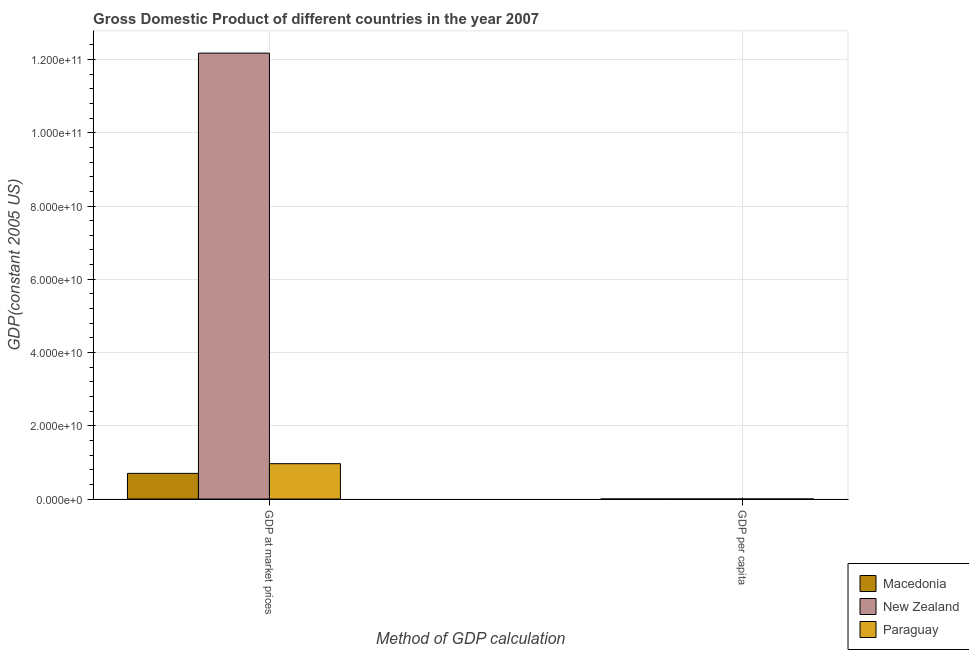How many different coloured bars are there?
Give a very brief answer. 3. Are the number of bars on each tick of the X-axis equal?
Provide a succinct answer. Yes. How many bars are there on the 2nd tick from the left?
Your response must be concise. 3. How many bars are there on the 1st tick from the right?
Keep it short and to the point. 3. What is the label of the 2nd group of bars from the left?
Offer a very short reply. GDP per capita. What is the gdp per capita in Macedonia?
Give a very brief answer. 3415.22. Across all countries, what is the maximum gdp at market prices?
Make the answer very short. 1.22e+11. Across all countries, what is the minimum gdp per capita?
Make the answer very short. 1617.6. In which country was the gdp at market prices maximum?
Your answer should be very brief. New Zealand. In which country was the gdp at market prices minimum?
Your answer should be very brief. Macedonia. What is the total gdp per capita in the graph?
Keep it short and to the point. 3.39e+04. What is the difference between the gdp per capita in New Zealand and that in Paraguay?
Your answer should be compact. 2.72e+04. What is the difference between the gdp at market prices in New Zealand and the gdp per capita in Macedonia?
Provide a succinct answer. 1.22e+11. What is the average gdp at market prices per country?
Your response must be concise. 4.61e+1. What is the difference between the gdp per capita and gdp at market prices in Macedonia?
Your response must be concise. -7.01e+09. In how many countries, is the gdp at market prices greater than 112000000000 US$?
Offer a terse response. 1. What is the ratio of the gdp at market prices in Macedonia to that in Paraguay?
Ensure brevity in your answer.  0.73. Is the gdp at market prices in Macedonia less than that in Paraguay?
Keep it short and to the point. Yes. What does the 3rd bar from the left in GDP at market prices represents?
Ensure brevity in your answer.  Paraguay. What does the 1st bar from the right in GDP at market prices represents?
Keep it short and to the point. Paraguay. How many bars are there?
Make the answer very short. 6. What is the difference between two consecutive major ticks on the Y-axis?
Give a very brief answer. 2.00e+1. Are the values on the major ticks of Y-axis written in scientific E-notation?
Give a very brief answer. Yes. Does the graph contain any zero values?
Ensure brevity in your answer.  No. Where does the legend appear in the graph?
Provide a succinct answer. Bottom right. How many legend labels are there?
Make the answer very short. 3. How are the legend labels stacked?
Make the answer very short. Vertical. What is the title of the graph?
Provide a short and direct response. Gross Domestic Product of different countries in the year 2007. Does "Small states" appear as one of the legend labels in the graph?
Your response must be concise. No. What is the label or title of the X-axis?
Your response must be concise. Method of GDP calculation. What is the label or title of the Y-axis?
Make the answer very short. GDP(constant 2005 US). What is the GDP(constant 2005 US) of Macedonia in GDP at market prices?
Your answer should be compact. 7.01e+09. What is the GDP(constant 2005 US) in New Zealand in GDP at market prices?
Make the answer very short. 1.22e+11. What is the GDP(constant 2005 US) of Paraguay in GDP at market prices?
Ensure brevity in your answer.  9.65e+09. What is the GDP(constant 2005 US) of Macedonia in GDP per capita?
Your answer should be compact. 3415.22. What is the GDP(constant 2005 US) in New Zealand in GDP per capita?
Ensure brevity in your answer.  2.88e+04. What is the GDP(constant 2005 US) of Paraguay in GDP per capita?
Offer a terse response. 1617.6. Across all Method of GDP calculation, what is the maximum GDP(constant 2005 US) in Macedonia?
Your answer should be very brief. 7.01e+09. Across all Method of GDP calculation, what is the maximum GDP(constant 2005 US) in New Zealand?
Offer a terse response. 1.22e+11. Across all Method of GDP calculation, what is the maximum GDP(constant 2005 US) of Paraguay?
Your response must be concise. 9.65e+09. Across all Method of GDP calculation, what is the minimum GDP(constant 2005 US) in Macedonia?
Offer a terse response. 3415.22. Across all Method of GDP calculation, what is the minimum GDP(constant 2005 US) of New Zealand?
Keep it short and to the point. 2.88e+04. Across all Method of GDP calculation, what is the minimum GDP(constant 2005 US) in Paraguay?
Give a very brief answer. 1617.6. What is the total GDP(constant 2005 US) in Macedonia in the graph?
Make the answer very short. 7.01e+09. What is the total GDP(constant 2005 US) of New Zealand in the graph?
Ensure brevity in your answer.  1.22e+11. What is the total GDP(constant 2005 US) of Paraguay in the graph?
Offer a very short reply. 9.65e+09. What is the difference between the GDP(constant 2005 US) in Macedonia in GDP at market prices and that in GDP per capita?
Make the answer very short. 7.01e+09. What is the difference between the GDP(constant 2005 US) in New Zealand in GDP at market prices and that in GDP per capita?
Offer a very short reply. 1.22e+11. What is the difference between the GDP(constant 2005 US) in Paraguay in GDP at market prices and that in GDP per capita?
Provide a short and direct response. 9.65e+09. What is the difference between the GDP(constant 2005 US) of Macedonia in GDP at market prices and the GDP(constant 2005 US) of New Zealand in GDP per capita?
Offer a very short reply. 7.01e+09. What is the difference between the GDP(constant 2005 US) in Macedonia in GDP at market prices and the GDP(constant 2005 US) in Paraguay in GDP per capita?
Offer a very short reply. 7.01e+09. What is the difference between the GDP(constant 2005 US) of New Zealand in GDP at market prices and the GDP(constant 2005 US) of Paraguay in GDP per capita?
Offer a very short reply. 1.22e+11. What is the average GDP(constant 2005 US) of Macedonia per Method of GDP calculation?
Your answer should be very brief. 3.50e+09. What is the average GDP(constant 2005 US) of New Zealand per Method of GDP calculation?
Provide a short and direct response. 6.09e+1. What is the average GDP(constant 2005 US) in Paraguay per Method of GDP calculation?
Offer a terse response. 4.83e+09. What is the difference between the GDP(constant 2005 US) in Macedonia and GDP(constant 2005 US) in New Zealand in GDP at market prices?
Provide a succinct answer. -1.15e+11. What is the difference between the GDP(constant 2005 US) in Macedonia and GDP(constant 2005 US) in Paraguay in GDP at market prices?
Provide a succinct answer. -2.64e+09. What is the difference between the GDP(constant 2005 US) in New Zealand and GDP(constant 2005 US) in Paraguay in GDP at market prices?
Make the answer very short. 1.12e+11. What is the difference between the GDP(constant 2005 US) in Macedonia and GDP(constant 2005 US) in New Zealand in GDP per capita?
Offer a terse response. -2.54e+04. What is the difference between the GDP(constant 2005 US) in Macedonia and GDP(constant 2005 US) in Paraguay in GDP per capita?
Make the answer very short. 1797.62. What is the difference between the GDP(constant 2005 US) in New Zealand and GDP(constant 2005 US) in Paraguay in GDP per capita?
Offer a very short reply. 2.72e+04. What is the ratio of the GDP(constant 2005 US) of Macedonia in GDP at market prices to that in GDP per capita?
Make the answer very short. 2.05e+06. What is the ratio of the GDP(constant 2005 US) in New Zealand in GDP at market prices to that in GDP per capita?
Make the answer very short. 4.22e+06. What is the ratio of the GDP(constant 2005 US) of Paraguay in GDP at market prices to that in GDP per capita?
Give a very brief answer. 5.97e+06. What is the difference between the highest and the second highest GDP(constant 2005 US) of Macedonia?
Offer a terse response. 7.01e+09. What is the difference between the highest and the second highest GDP(constant 2005 US) in New Zealand?
Keep it short and to the point. 1.22e+11. What is the difference between the highest and the second highest GDP(constant 2005 US) in Paraguay?
Your answer should be compact. 9.65e+09. What is the difference between the highest and the lowest GDP(constant 2005 US) in Macedonia?
Your response must be concise. 7.01e+09. What is the difference between the highest and the lowest GDP(constant 2005 US) of New Zealand?
Provide a short and direct response. 1.22e+11. What is the difference between the highest and the lowest GDP(constant 2005 US) of Paraguay?
Ensure brevity in your answer.  9.65e+09. 